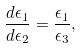Convert formula to latex. <formula><loc_0><loc_0><loc_500><loc_500>\frac { d \epsilon _ { 1 } } { d \epsilon _ { 2 } } = \frac { \epsilon _ { 1 } } { \epsilon _ { 3 } } ,</formula> 